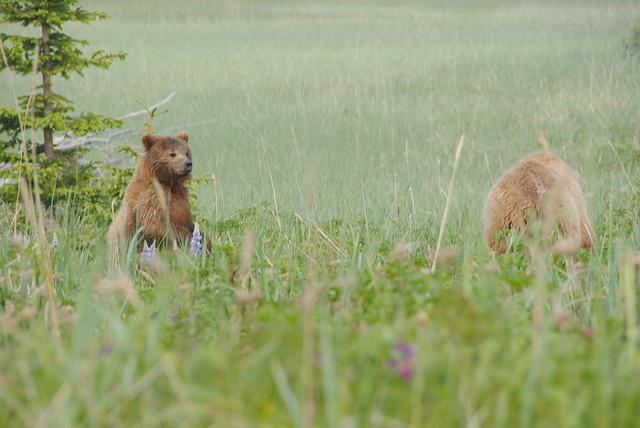How many bears are there?
Give a very brief answer. 2. Are all the bears facing the camera?
Quick response, please. No. Are there flowers?
Short answer required. Yes. 